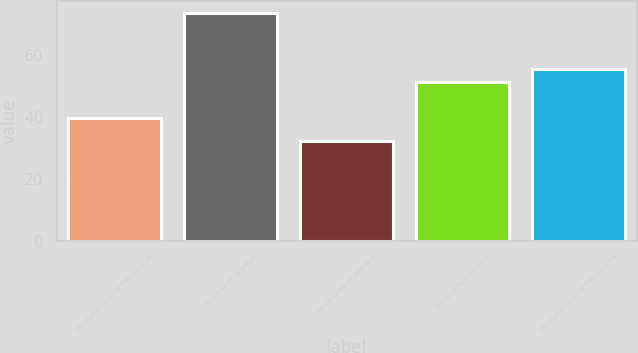<chart> <loc_0><loc_0><loc_500><loc_500><bar_chart><fcel>Outstanding as of February 28<fcel>Stock units granted<fcel>Stock units vested and<fcel>Stock units cancelled<fcel>Outstanding as of February 29<nl><fcel>39.81<fcel>73.76<fcel>32.35<fcel>51.29<fcel>55.43<nl></chart> 